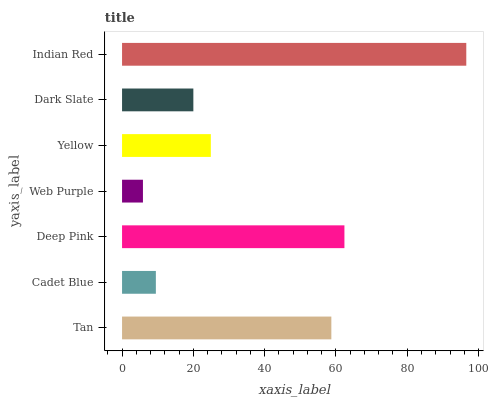Is Web Purple the minimum?
Answer yes or no. Yes. Is Indian Red the maximum?
Answer yes or no. Yes. Is Cadet Blue the minimum?
Answer yes or no. No. Is Cadet Blue the maximum?
Answer yes or no. No. Is Tan greater than Cadet Blue?
Answer yes or no. Yes. Is Cadet Blue less than Tan?
Answer yes or no. Yes. Is Cadet Blue greater than Tan?
Answer yes or no. No. Is Tan less than Cadet Blue?
Answer yes or no. No. Is Yellow the high median?
Answer yes or no. Yes. Is Yellow the low median?
Answer yes or no. Yes. Is Tan the high median?
Answer yes or no. No. Is Tan the low median?
Answer yes or no. No. 